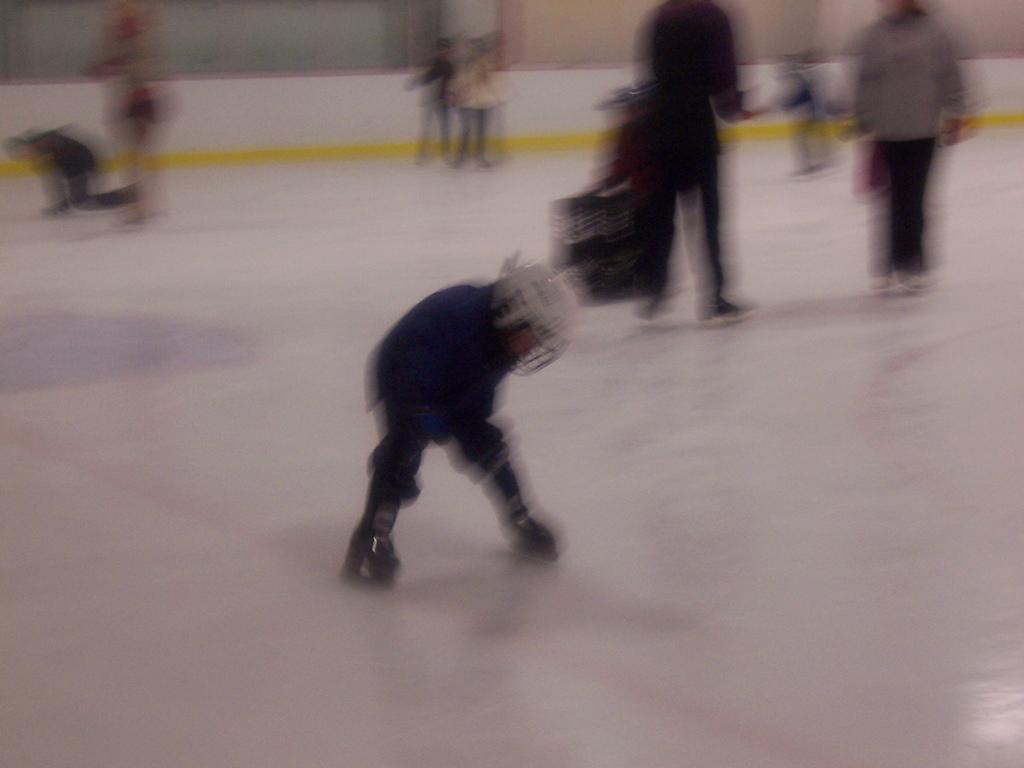Could you give a brief overview of what you see in this image? It is a blur picture some people are skating on the ice floor. 